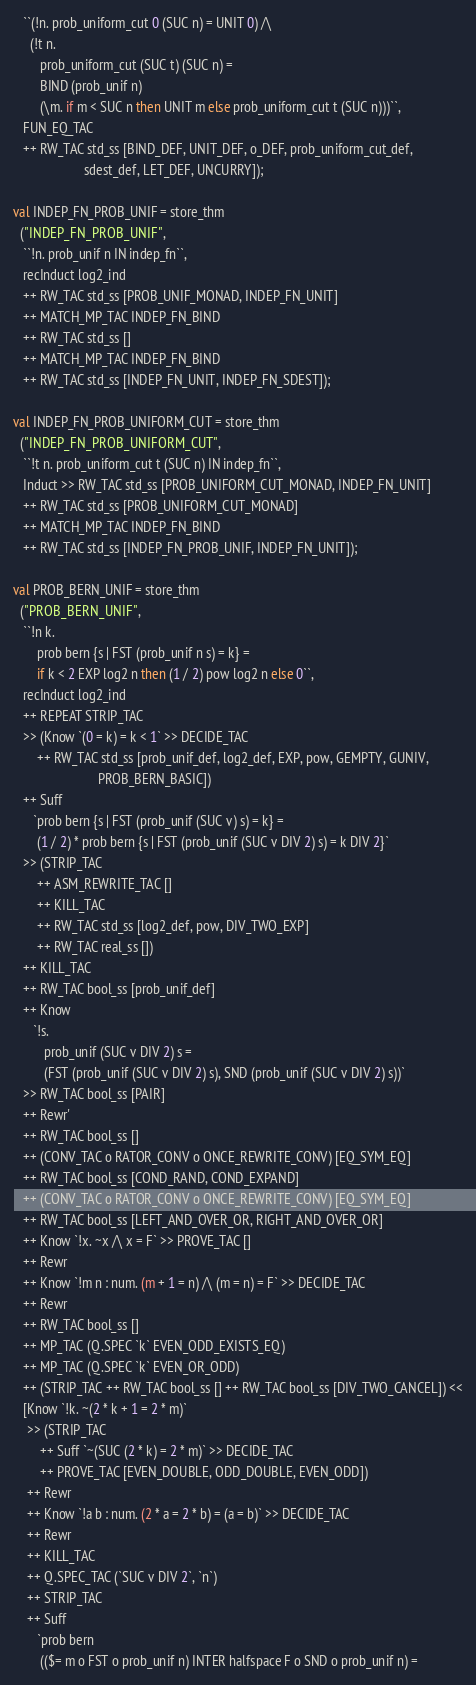<code> <loc_0><loc_0><loc_500><loc_500><_SML_>   ``(!n. prob_uniform_cut 0 (SUC n) = UNIT 0) /\
     (!t n.
        prob_uniform_cut (SUC t) (SUC n) =
        BIND (prob_unif n)
        (\m. if m < SUC n then UNIT m else prob_uniform_cut t (SUC n)))``,
   FUN_EQ_TAC
   ++ RW_TAC std_ss [BIND_DEF, UNIT_DEF, o_DEF, prob_uniform_cut_def,
                     sdest_def, LET_DEF, UNCURRY]);

val INDEP_FN_PROB_UNIF = store_thm
  ("INDEP_FN_PROB_UNIF",
   ``!n. prob_unif n IN indep_fn``,
   recInduct log2_ind
   ++ RW_TAC std_ss [PROB_UNIF_MONAD, INDEP_FN_UNIT]
   ++ MATCH_MP_TAC INDEP_FN_BIND
   ++ RW_TAC std_ss []
   ++ MATCH_MP_TAC INDEP_FN_BIND
   ++ RW_TAC std_ss [INDEP_FN_UNIT, INDEP_FN_SDEST]);

val INDEP_FN_PROB_UNIFORM_CUT = store_thm
  ("INDEP_FN_PROB_UNIFORM_CUT",
   ``!t n. prob_uniform_cut t (SUC n) IN indep_fn``,
   Induct >> RW_TAC std_ss [PROB_UNIFORM_CUT_MONAD, INDEP_FN_UNIT]
   ++ RW_TAC std_ss [PROB_UNIFORM_CUT_MONAD]
   ++ MATCH_MP_TAC INDEP_FN_BIND
   ++ RW_TAC std_ss [INDEP_FN_PROB_UNIF, INDEP_FN_UNIT]);

val PROB_BERN_UNIF = store_thm
  ("PROB_BERN_UNIF",
   ``!n k.
       prob bern {s | FST (prob_unif n s) = k} =
       if k < 2 EXP log2 n then (1 / 2) pow log2 n else 0``,
   recInduct log2_ind
   ++ REPEAT STRIP_TAC
   >> (Know `(0 = k) = k < 1` >> DECIDE_TAC
       ++ RW_TAC std_ss [prob_unif_def, log2_def, EXP, pow, GEMPTY, GUNIV,
                         PROB_BERN_BASIC])
   ++ Suff
      `prob bern {s | FST (prob_unif (SUC v) s) = k} =
       (1 / 2) * prob bern {s | FST (prob_unif (SUC v DIV 2) s) = k DIV 2}`
   >> (STRIP_TAC
       ++ ASM_REWRITE_TAC []
       ++ KILL_TAC
       ++ RW_TAC std_ss [log2_def, pow, DIV_TWO_EXP]
       ++ RW_TAC real_ss [])
   ++ KILL_TAC
   ++ RW_TAC bool_ss [prob_unif_def]
   ++ Know
      `!s.
         prob_unif (SUC v DIV 2) s =
         (FST (prob_unif (SUC v DIV 2) s), SND (prob_unif (SUC v DIV 2) s))`
   >> RW_TAC bool_ss [PAIR]
   ++ Rewr'
   ++ RW_TAC bool_ss []
   ++ (CONV_TAC o RATOR_CONV o ONCE_REWRITE_CONV) [EQ_SYM_EQ]
   ++ RW_TAC bool_ss [COND_RAND, COND_EXPAND]
   ++ (CONV_TAC o RATOR_CONV o ONCE_REWRITE_CONV) [EQ_SYM_EQ]
   ++ RW_TAC bool_ss [LEFT_AND_OVER_OR, RIGHT_AND_OVER_OR]
   ++ Know `!x. ~x /\ x = F` >> PROVE_TAC []
   ++ Rewr
   ++ Know `!m n : num. (m + 1 = n) /\ (m = n) = F` >> DECIDE_TAC
   ++ Rewr
   ++ RW_TAC bool_ss []
   ++ MP_TAC (Q.SPEC `k` EVEN_ODD_EXISTS_EQ)
   ++ MP_TAC (Q.SPEC `k` EVEN_OR_ODD)
   ++ (STRIP_TAC ++ RW_TAC bool_ss [] ++ RW_TAC bool_ss [DIV_TWO_CANCEL]) <<
   [Know `!k. ~(2 * k + 1 = 2 * m)`
    >> (STRIP_TAC
        ++ Suff `~(SUC (2 * k) = 2 * m)` >> DECIDE_TAC
        ++ PROVE_TAC [EVEN_DOUBLE, ODD_DOUBLE, EVEN_ODD])
    ++ Rewr
    ++ Know `!a b : num. (2 * a = 2 * b) = (a = b)` >> DECIDE_TAC
    ++ Rewr
    ++ KILL_TAC
    ++ Q.SPEC_TAC (`SUC v DIV 2`, `n`)
    ++ STRIP_TAC
    ++ Suff
       `prob bern
        (($= m o FST o prob_unif n) INTER halfspace F o SND o prob_unif n) =</code> 